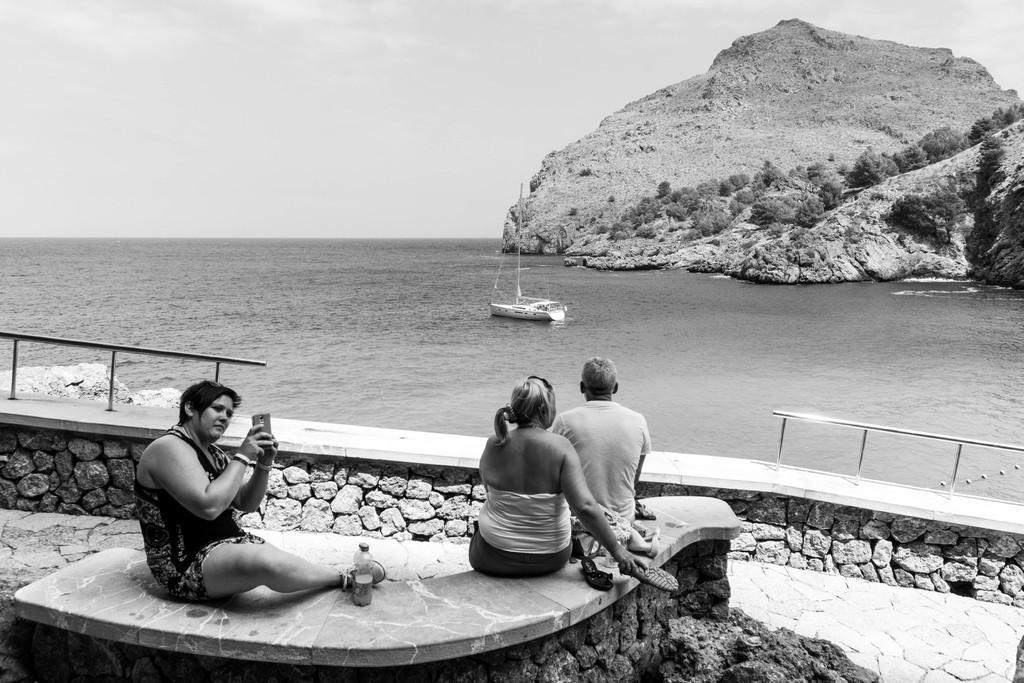Can you describe this image briefly? In this image there is the sky towards the top of the image, there are mountains towards the right of the image, there are trees on the mountain, there is water, there is a boat, there is a man sitting, there are two women sitting, they are holding an object, there is a water bottle, there is an object towards the bottom of the image. 